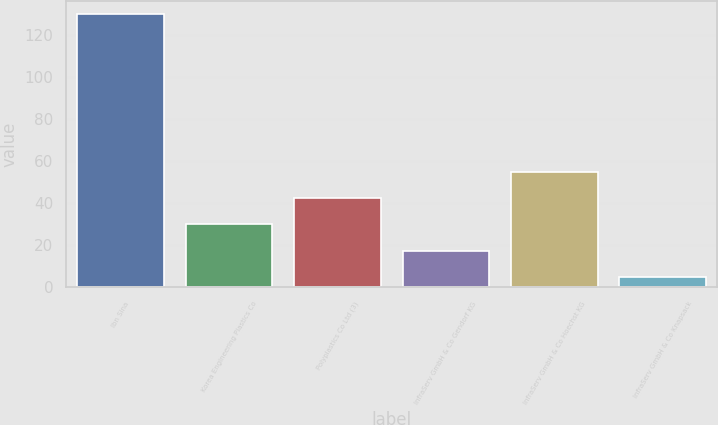<chart> <loc_0><loc_0><loc_500><loc_500><bar_chart><fcel>Ibn Sina<fcel>Korea Engineering Plastics Co<fcel>Polyplastics Co Ltd (3)<fcel>InfraServ GmbH & Co Gendorf KG<fcel>InfraServ GmbH & Co Hoechst KG<fcel>InfraServ GmbH & Co Knapsack<nl><fcel>130<fcel>30<fcel>42.5<fcel>17.5<fcel>55<fcel>5<nl></chart> 